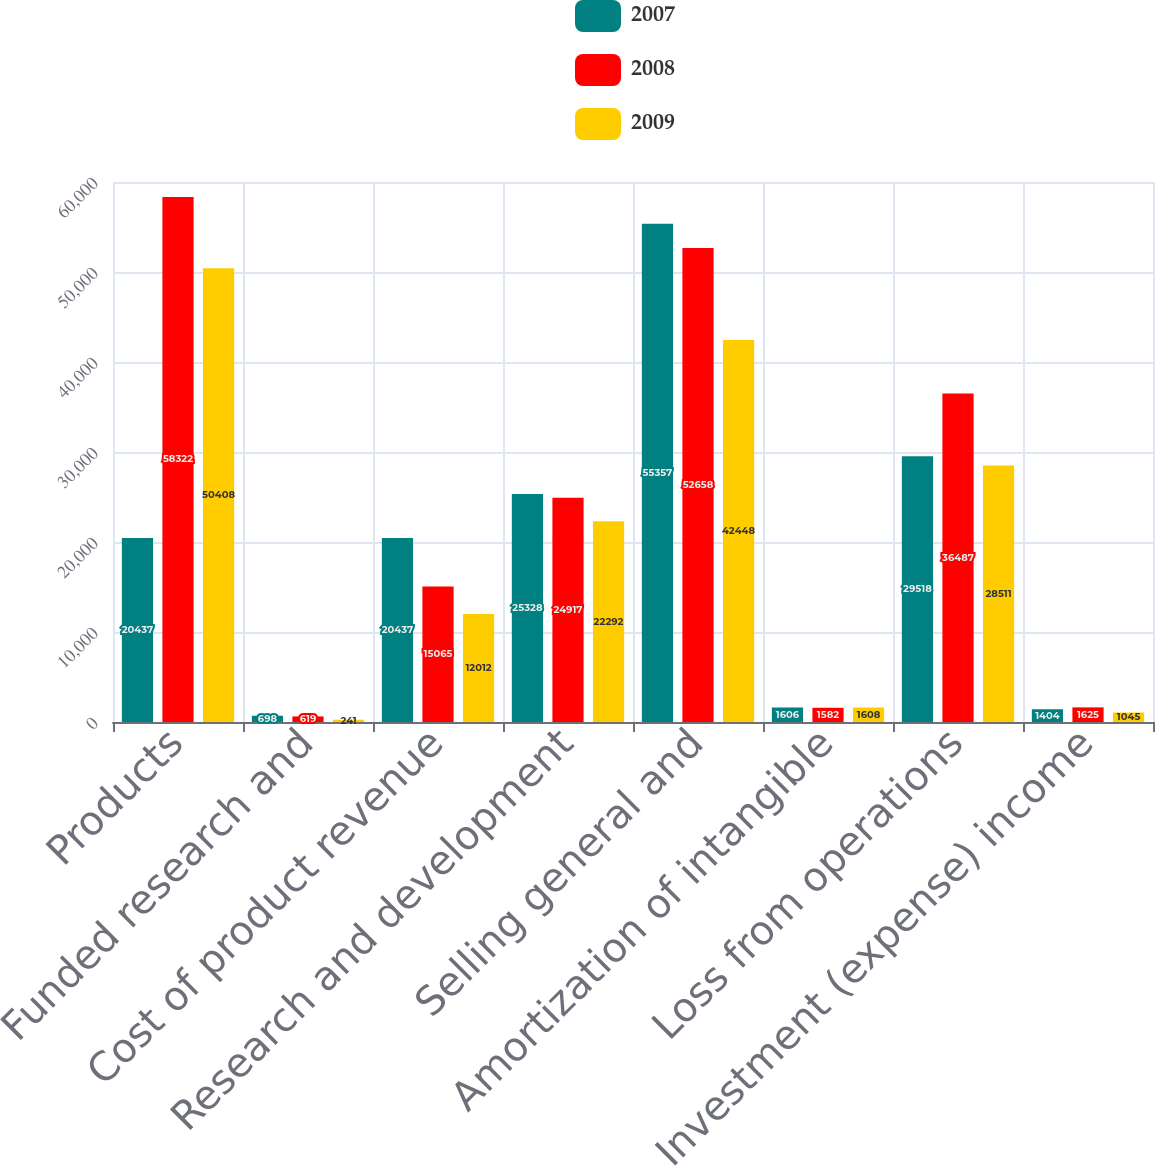<chart> <loc_0><loc_0><loc_500><loc_500><stacked_bar_chart><ecel><fcel>Products<fcel>Funded research and<fcel>Cost of product revenue<fcel>Research and development<fcel>Selling general and<fcel>Amortization of intangible<fcel>Loss from operations<fcel>Investment (expense) income<nl><fcel>2007<fcel>20437<fcel>698<fcel>20437<fcel>25328<fcel>55357<fcel>1606<fcel>29518<fcel>1404<nl><fcel>2008<fcel>58322<fcel>619<fcel>15065<fcel>24917<fcel>52658<fcel>1582<fcel>36487<fcel>1625<nl><fcel>2009<fcel>50408<fcel>241<fcel>12012<fcel>22292<fcel>42448<fcel>1608<fcel>28511<fcel>1045<nl></chart> 